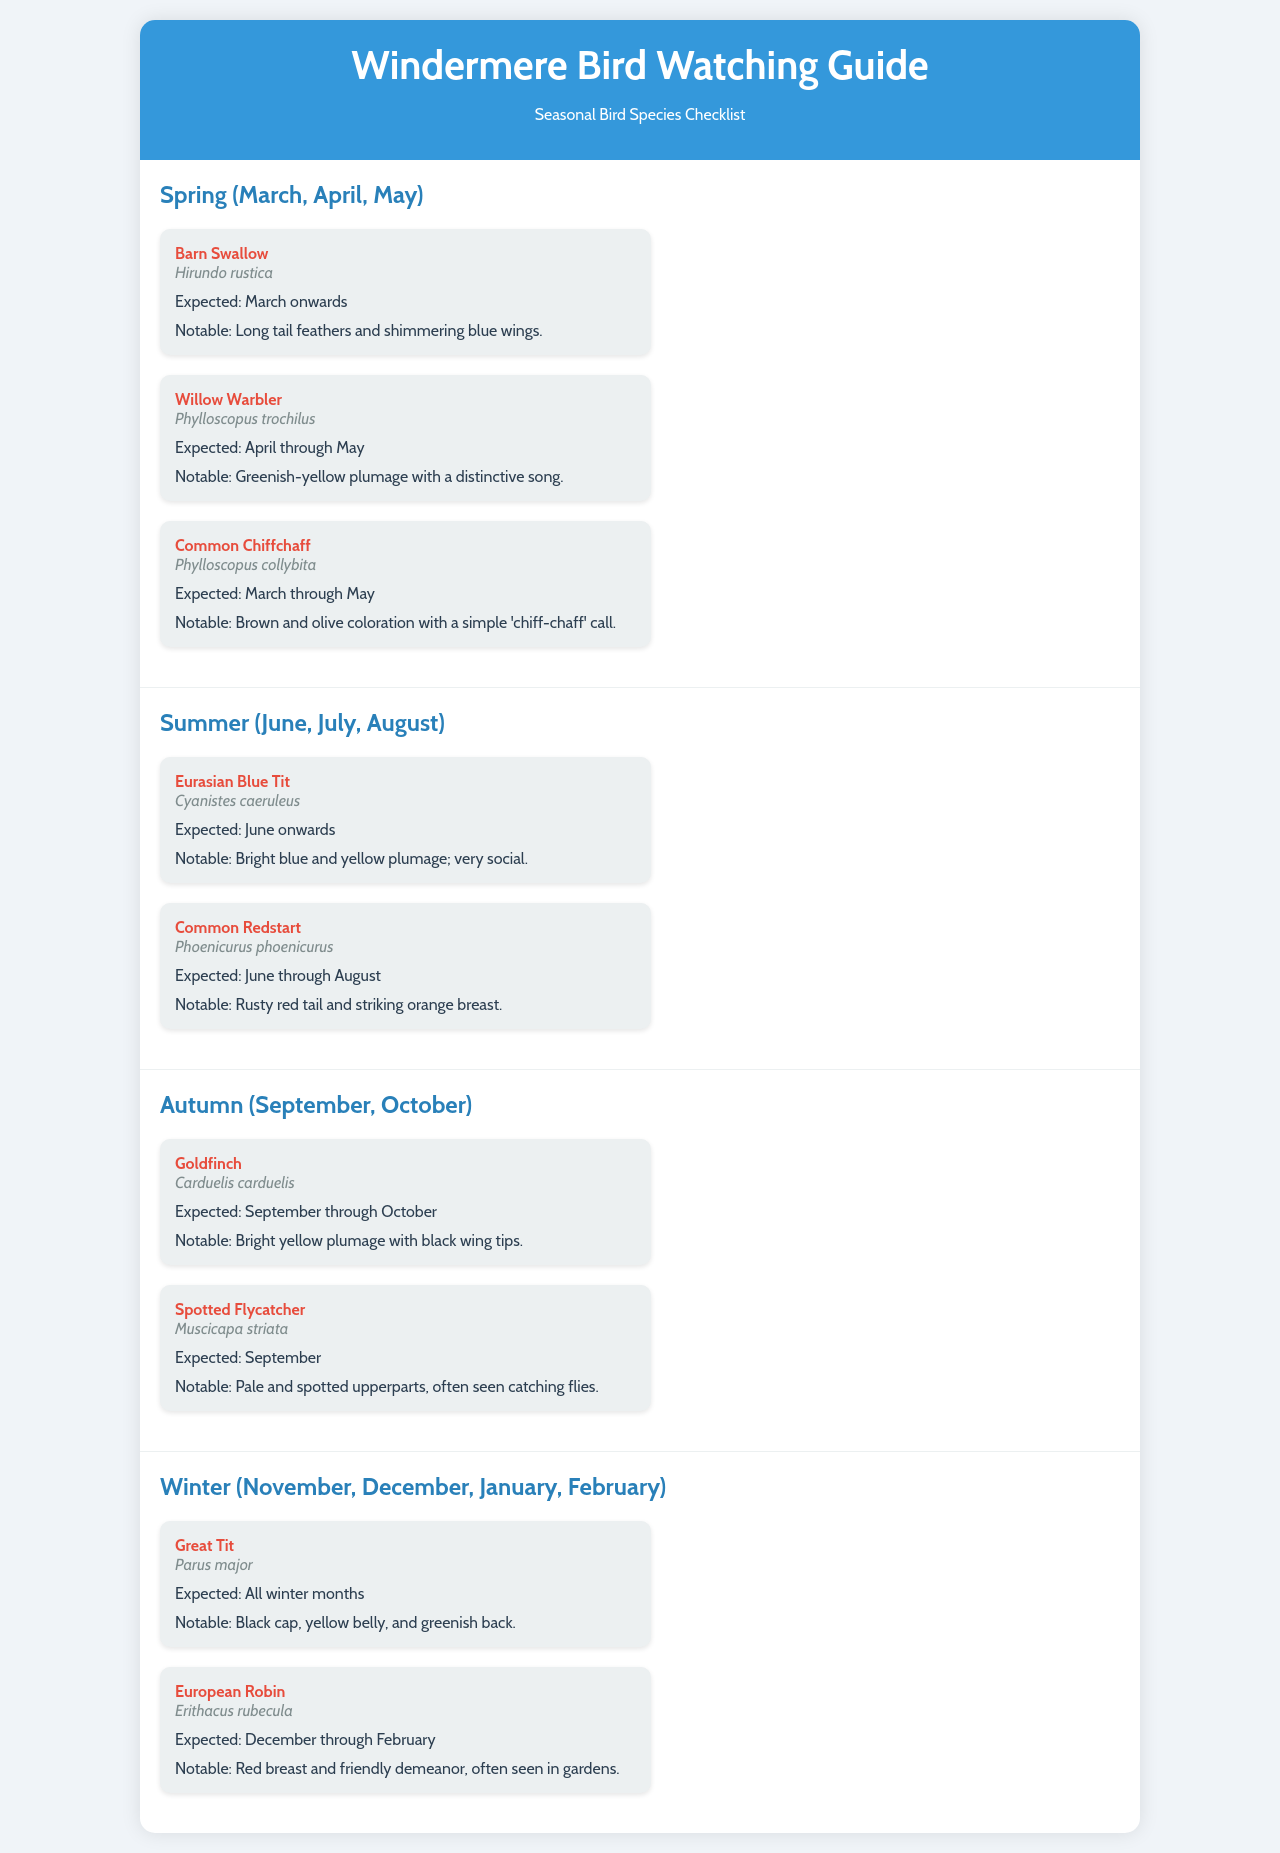What bird is expected from March onwards? The document states that the Barn Swallow is expected from March onwards.
Answer: Barn Swallow What is the scientific name of the Common Redstart? The document provides the scientific name as Phoenicurus phoenicurus.
Answer: Phoenicurus phoenicurus During which months is the Goldfinch expected? The document indicates that the Goldfinch is expected from September through October.
Answer: September through October Which bird has a notable red breast? The document mentions that the European Robin has a notable red breast.
Answer: European Robin What notable feature is associated with the Willow Warbler? The document highlights the greenish-yellow plumage with a distinctive song as a notable feature of the Willow Warbler.
Answer: Greenish-yellow plumage with a distinctive song Which bird species is expected during all winter months? The document clearly states that the Great Tit is expected during all winter months.
Answer: Great Tit How many species are listed in the Spring section? The document lists three species in the Spring section.
Answer: Three What is a common characteristic of the Eurasian Blue Tit? The document notes that the Eurasian Blue Tit has bright blue and yellow plumage and is very social.
Answer: Bright blue and yellow plumage; very social What season features the Spotted Flycatcher? The document indicates that the Spotted Flycatcher is featured in the Autumn season.
Answer: Autumn 